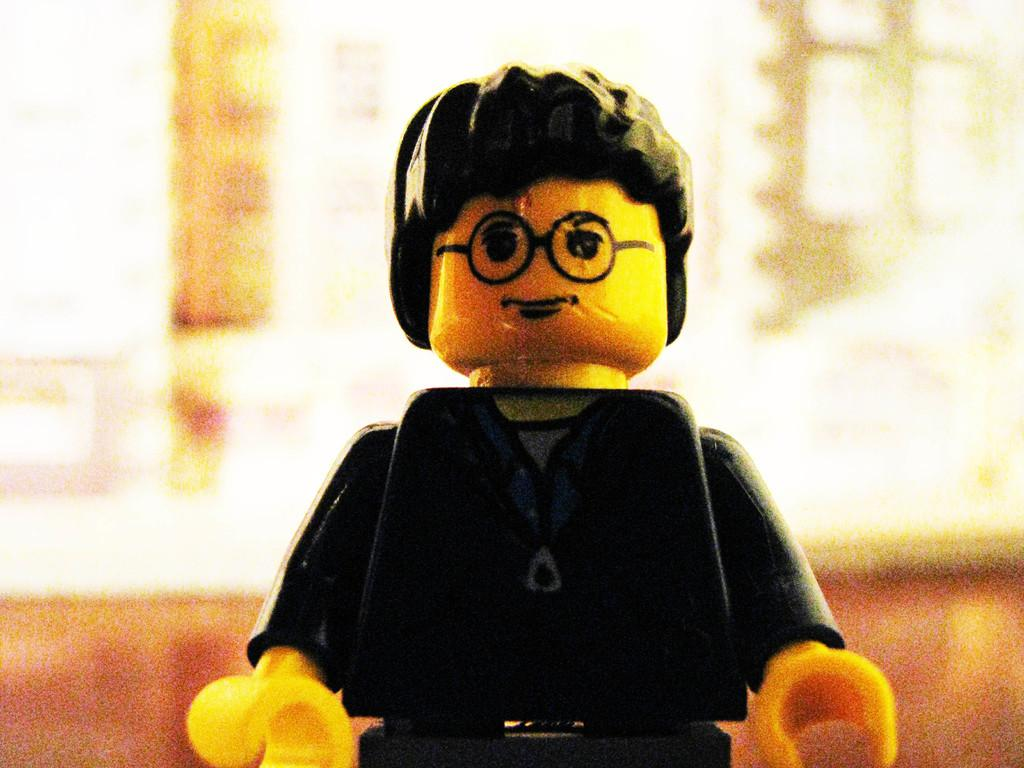What is the main subject in the middle of the image? There is a toy in the middle of the image. Can you describe the background of the image? The background of the image is blurred. What type of mine is visible in the background of the image? There is no mine present in the image; the background is blurred. What kind of insurance policy is related to the toy in the image? There is no mention of insurance in the image, and the toy is not associated with any insurance policy. 